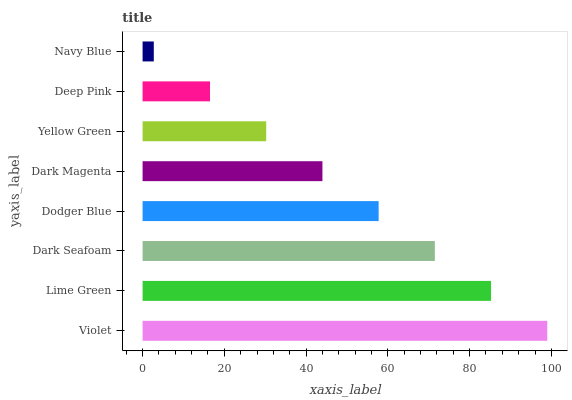Is Navy Blue the minimum?
Answer yes or no. Yes. Is Violet the maximum?
Answer yes or no. Yes. Is Lime Green the minimum?
Answer yes or no. No. Is Lime Green the maximum?
Answer yes or no. No. Is Violet greater than Lime Green?
Answer yes or no. Yes. Is Lime Green less than Violet?
Answer yes or no. Yes. Is Lime Green greater than Violet?
Answer yes or no. No. Is Violet less than Lime Green?
Answer yes or no. No. Is Dodger Blue the high median?
Answer yes or no. Yes. Is Dark Magenta the low median?
Answer yes or no. Yes. Is Deep Pink the high median?
Answer yes or no. No. Is Deep Pink the low median?
Answer yes or no. No. 